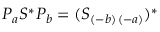<formula> <loc_0><loc_0><loc_500><loc_500>P _ { a } S ^ { \ast } P _ { b } = ( S _ { ( - b ) \, ( - a ) } ) ^ { \ast }</formula> 